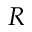<formula> <loc_0><loc_0><loc_500><loc_500>R</formula> 